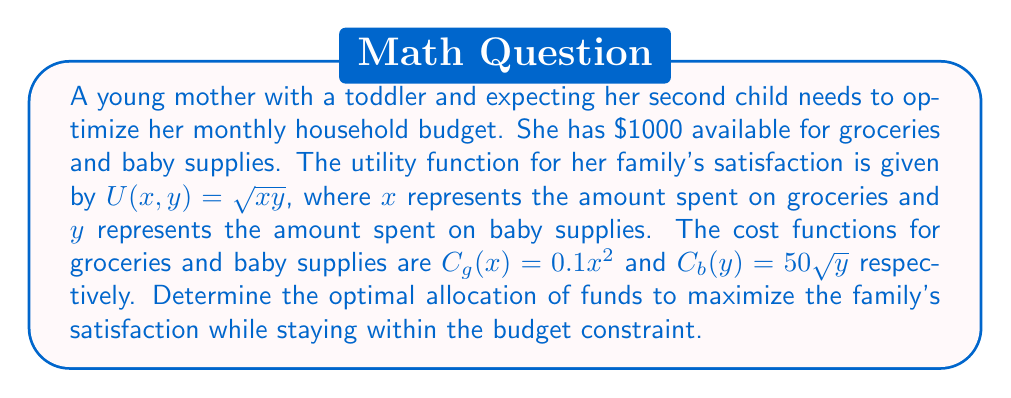Show me your answer to this math problem. 1. Define the optimization problem:
   Maximize $U(x,y) = \sqrt{xy}$
   Subject to: $C_g(x) + C_b(y) \leq 1000$

2. Substitute the cost functions:
   $0.1x^2 + 50\sqrt{y} \leq 1000$

3. Set up the Lagrangian function:
   $L(x,y,\lambda) = \sqrt{xy} - \lambda(0.1x^2 + 50\sqrt{y} - 1000)$

4. Calculate partial derivatives and set them to zero:
   $$\frac{\partial L}{\partial x} = \frac{y}{2\sqrt{xy}} - 0.2\lambda x = 0$$
   $$\frac{\partial L}{\partial y} = \frac{x}{2\sqrt{xy}} - 25\lambda y^{-1/2} = 0$$
   $$\frac{\partial L}{\partial \lambda} = 0.1x^2 + 50\sqrt{y} - 1000 = 0$$

5. From the first two equations:
   $\frac{y}{x} = 0.4\lambda x^2$
   $\frac{x}{y} = 50\lambda y^{-1/2}$

6. Multiply these equations:
   $1 = 20\lambda^2 x^2 y^{-1/2}$

7. Substitute $y = 0.4\lambda x^3$ from step 5 into step 6:
   $1 = 20\lambda^2 x^2 (0.4\lambda x^3)^{-1/2}$
   $1 = 20\lambda^2 x^2 (\lambda^{-1/2} x^{-3/2})$
   $1 = 20\lambda^{3/2} x^{1/2}$
   $x = \frac{1}{400\lambda^3}$

8. Substitute this into the budget constraint:
   $0.1(\frac{1}{400\lambda^3})^2 + 50\sqrt{y} = 1000$
   $\frac{1}{1,600,000\lambda^6} + 50\sqrt{y} = 1000$

9. Solve numerically (using software or iterative methods) to find:
   $\lambda \approx 0.001425$
   $x \approx 686.81$
   $y \approx 156.25$

10. Verify the budget constraint:
    $0.1(686.81)^2 + 50\sqrt{156.25} \approx 1000$
Answer: Groceries: $686.81, Baby supplies: $156.25 